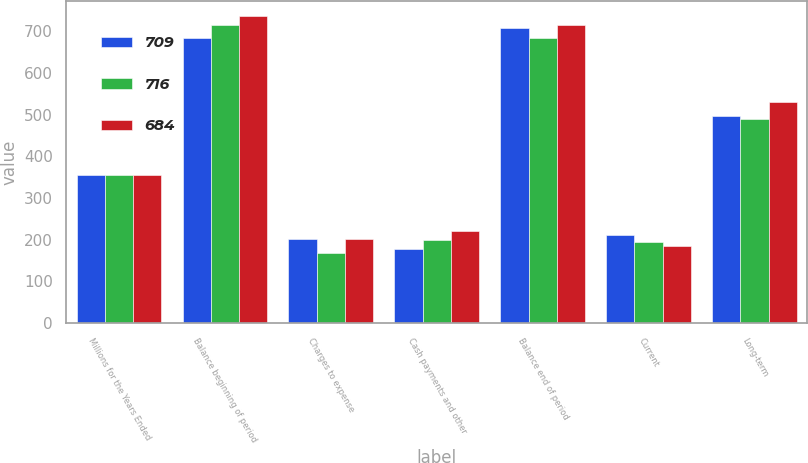<chart> <loc_0><loc_0><loc_500><loc_500><stacked_bar_chart><ecel><fcel>Millions for the Years Ended<fcel>Balance beginning of period<fcel>Charges to expense<fcel>Cash payments and other<fcel>Balance end of period<fcel>Current<fcel>Long-term<nl><fcel>709<fcel>356<fcel>684<fcel>202<fcel>177<fcel>709<fcel>211<fcel>498<nl><fcel>716<fcel>356<fcel>716<fcel>167<fcel>199<fcel>684<fcel>194<fcel>490<nl><fcel>684<fcel>356<fcel>736<fcel>202<fcel>222<fcel>716<fcel>185<fcel>531<nl></chart> 